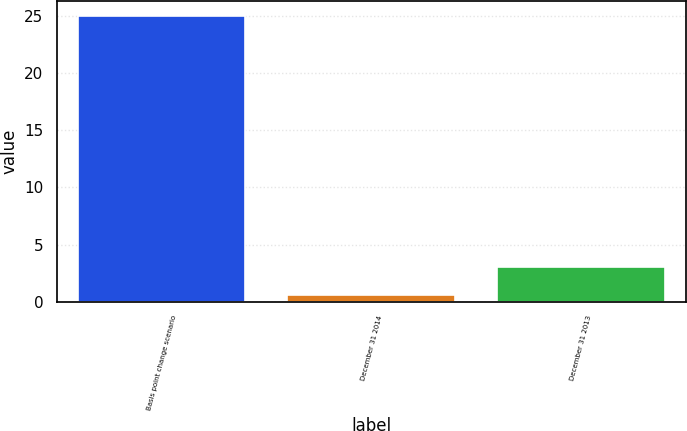Convert chart. <chart><loc_0><loc_0><loc_500><loc_500><bar_chart><fcel>Basis point change scenario<fcel>December 31 2014<fcel>December 31 2013<nl><fcel>25<fcel>0.6<fcel>3.04<nl></chart> 